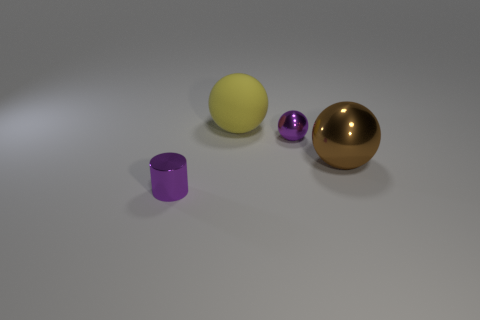How does the lighting in the scene affect the appearance of objects? The lighting in the scene is diffused, casting soft shadows and highlighting the reflective properties of the objects, adding depth and texture to the image. 